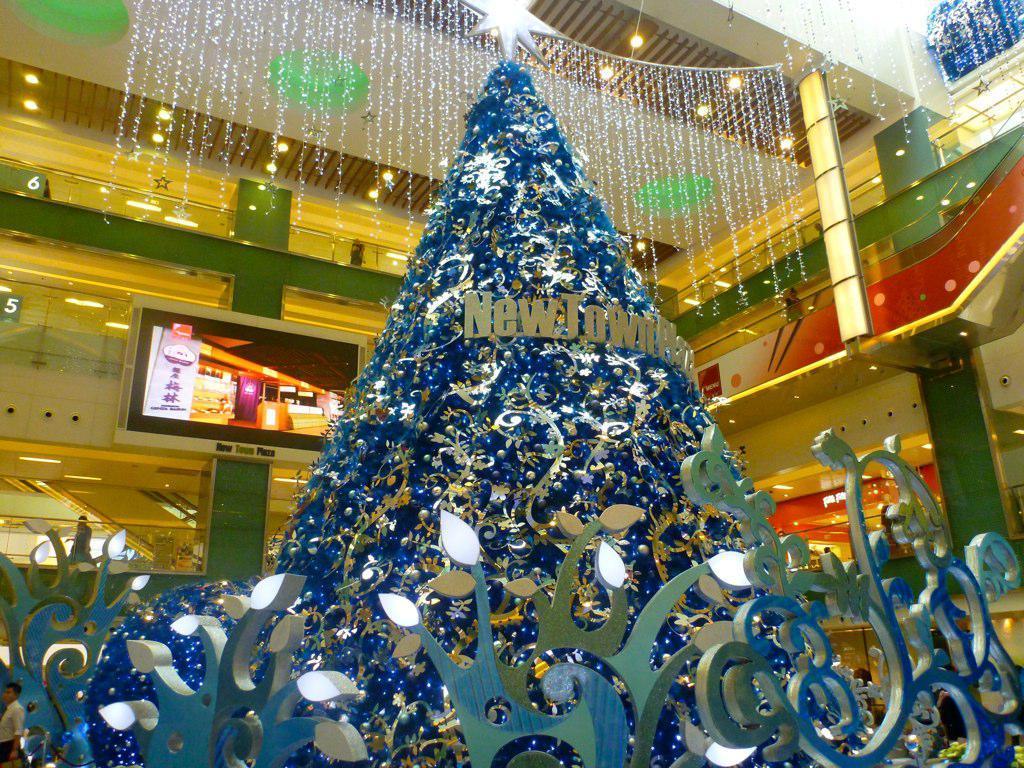In one or two sentences, can you explain what this image depicts? This image is taken indoors. In the middle of the image there is a Christmas tree decorated with many decorative items and a star and there is a fence. In the background there are many walls and pillars. There are a few lights and there is a screen. 